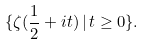<formula> <loc_0><loc_0><loc_500><loc_500>\{ \zeta ( \frac { 1 } { 2 } + i t ) \, | \, t \geq 0 \} .</formula> 